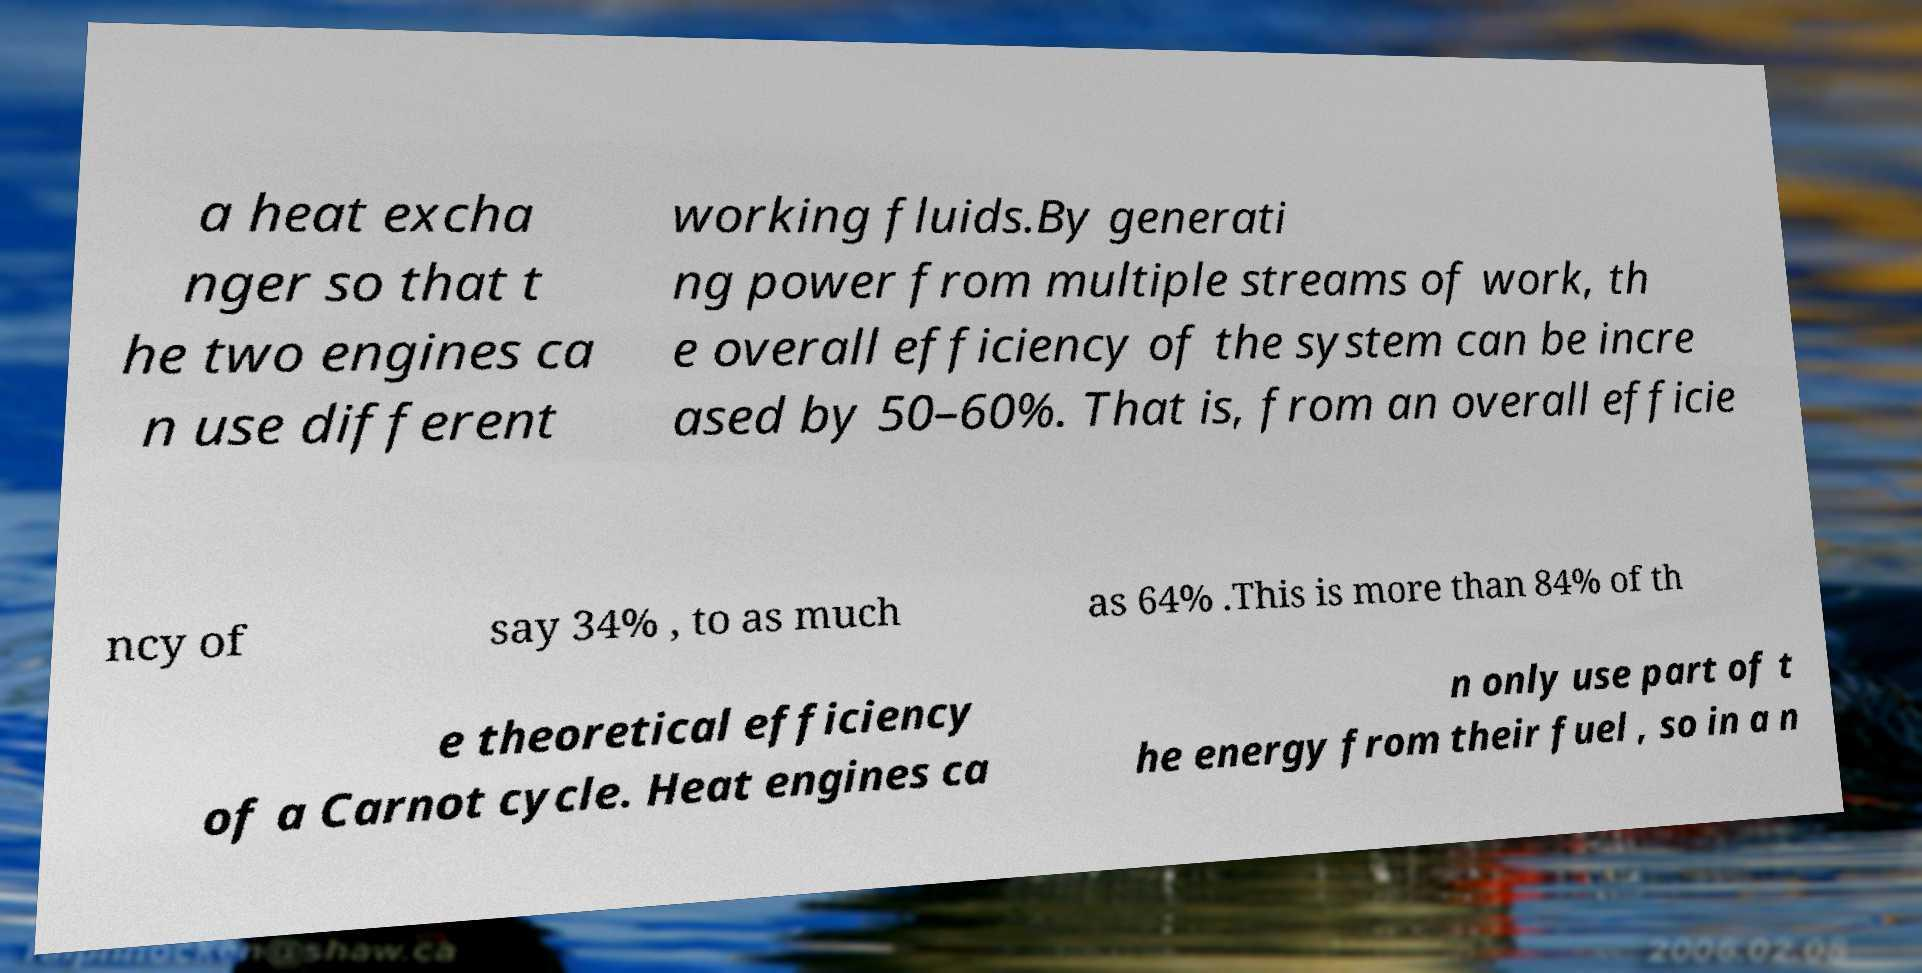Please identify and transcribe the text found in this image. a heat excha nger so that t he two engines ca n use different working fluids.By generati ng power from multiple streams of work, th e overall efficiency of the system can be incre ased by 50–60%. That is, from an overall efficie ncy of say 34% , to as much as 64% .This is more than 84% of th e theoretical efficiency of a Carnot cycle. Heat engines ca n only use part of t he energy from their fuel , so in a n 